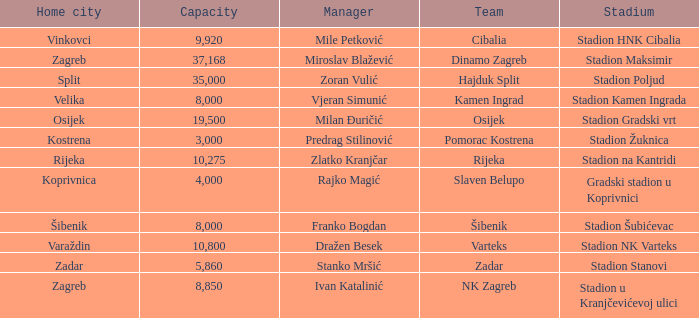What team that has a Home city of Zadar? Zadar. 